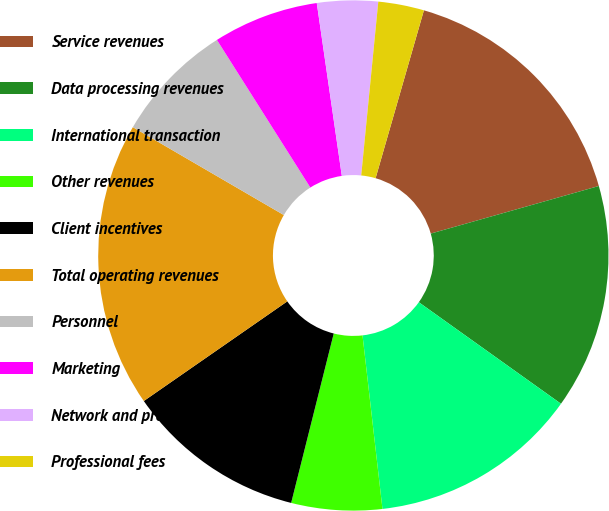Convert chart to OTSL. <chart><loc_0><loc_0><loc_500><loc_500><pie_chart><fcel>Service revenues<fcel>Data processing revenues<fcel>International transaction<fcel>Other revenues<fcel>Client incentives<fcel>Total operating revenues<fcel>Personnel<fcel>Marketing<fcel>Network and processing<fcel>Professional fees<nl><fcel>16.15%<fcel>14.26%<fcel>13.31%<fcel>5.74%<fcel>11.42%<fcel>18.05%<fcel>7.63%<fcel>6.69%<fcel>3.85%<fcel>2.9%<nl></chart> 